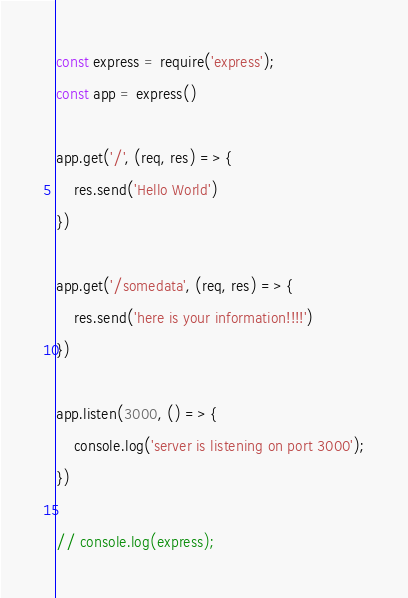<code> <loc_0><loc_0><loc_500><loc_500><_JavaScript_>const express = require('express');
const app = express()

app.get('/', (req, res) => {
    res.send('Hello World')
})

app.get('/somedata', (req, res) => {
    res.send('here is your information!!!!')
})

app.listen(3000, () => {
    console.log('server is listening on port 3000');
})

// console.log(express);
</code> 